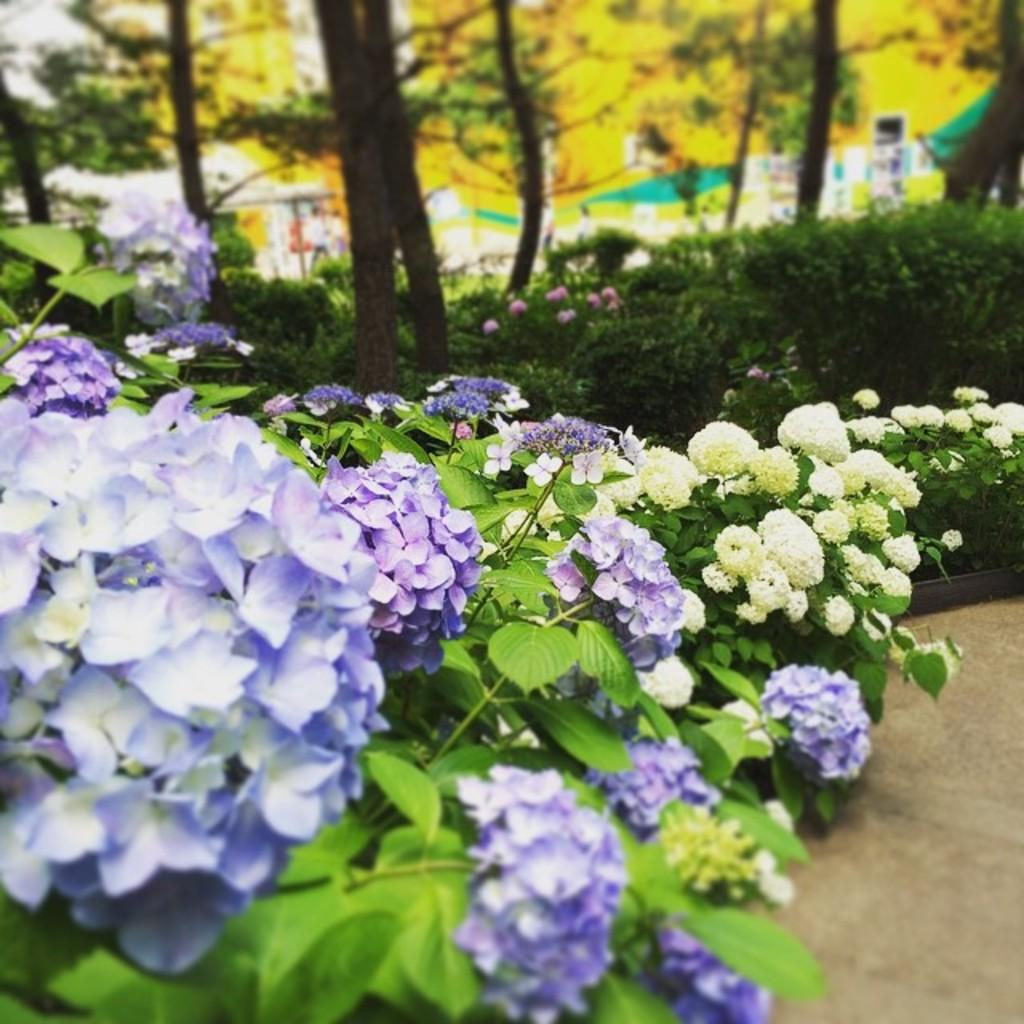What type of plants are visible in the image? There are plants with flowers in the image. What can be seen in the background of the image? There are trees in the background of the image. What type of ink is used to color the flowers on the plants in the image? The image does not provide information about the type of ink used to color the flowers on the plants. What flavor do the flowers on the plants have in the image? The image does not provide information about the flavor of the flowers on the plants. 